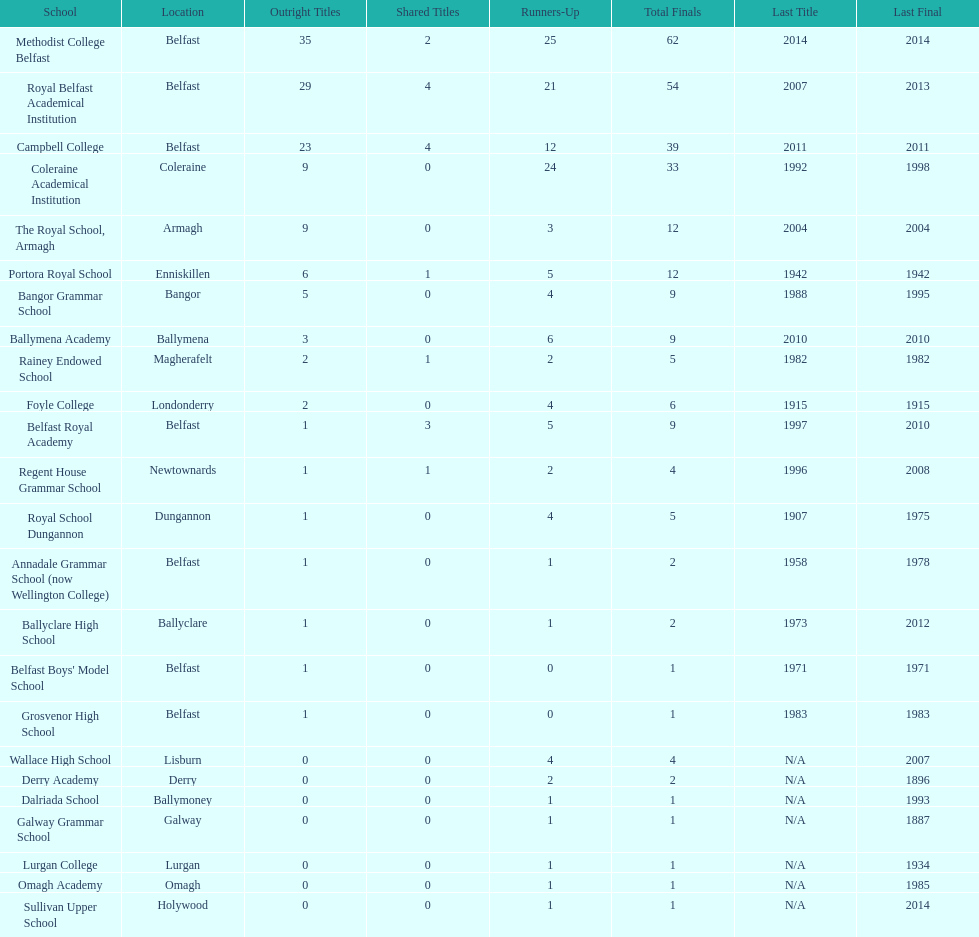Give me the full table as a dictionary. {'header': ['School', 'Location', 'Outright Titles', 'Shared Titles', 'Runners-Up', 'Total Finals', 'Last Title', 'Last Final'], 'rows': [['Methodist College Belfast', 'Belfast', '35', '2', '25', '62', '2014', '2014'], ['Royal Belfast Academical Institution', 'Belfast', '29', '4', '21', '54', '2007', '2013'], ['Campbell College', 'Belfast', '23', '4', '12', '39', '2011', '2011'], ['Coleraine Academical Institution', 'Coleraine', '9', '0', '24', '33', '1992', '1998'], ['The Royal School, Armagh', 'Armagh', '9', '0', '3', '12', '2004', '2004'], ['Portora Royal School', 'Enniskillen', '6', '1', '5', '12', '1942', '1942'], ['Bangor Grammar School', 'Bangor', '5', '0', '4', '9', '1988', '1995'], ['Ballymena Academy', 'Ballymena', '3', '0', '6', '9', '2010', '2010'], ['Rainey Endowed School', 'Magherafelt', '2', '1', '2', '5', '1982', '1982'], ['Foyle College', 'Londonderry', '2', '0', '4', '6', '1915', '1915'], ['Belfast Royal Academy', 'Belfast', '1', '3', '5', '9', '1997', '2010'], ['Regent House Grammar School', 'Newtownards', '1', '1', '2', '4', '1996', '2008'], ['Royal School Dungannon', 'Dungannon', '1', '0', '4', '5', '1907', '1975'], ['Annadale Grammar School (now Wellington College)', 'Belfast', '1', '0', '1', '2', '1958', '1978'], ['Ballyclare High School', 'Ballyclare', '1', '0', '1', '2', '1973', '2012'], ["Belfast Boys' Model School", 'Belfast', '1', '0', '0', '1', '1971', '1971'], ['Grosvenor High School', 'Belfast', '1', '0', '0', '1', '1983', '1983'], ['Wallace High School', 'Lisburn', '0', '0', '4', '4', 'N/A', '2007'], ['Derry Academy', 'Derry', '0', '0', '2', '2', 'N/A', '1896'], ['Dalriada School', 'Ballymoney', '0', '0', '1', '1', 'N/A', '1993'], ['Galway Grammar School', 'Galway', '0', '0', '1', '1', 'N/A', '1887'], ['Lurgan College', 'Lurgan', '0', '0', '1', '1', 'N/A', '1934'], ['Omagh Academy', 'Omagh', '0', '0', '1', '1', 'N/A', '1985'], ['Sullivan Upper School', 'Holywood', '0', '0', '1', '1', 'N/A', '2014']]} Was the total number of final matches at belfast royal academy higher or lower than that at ballyclare high school? More. 